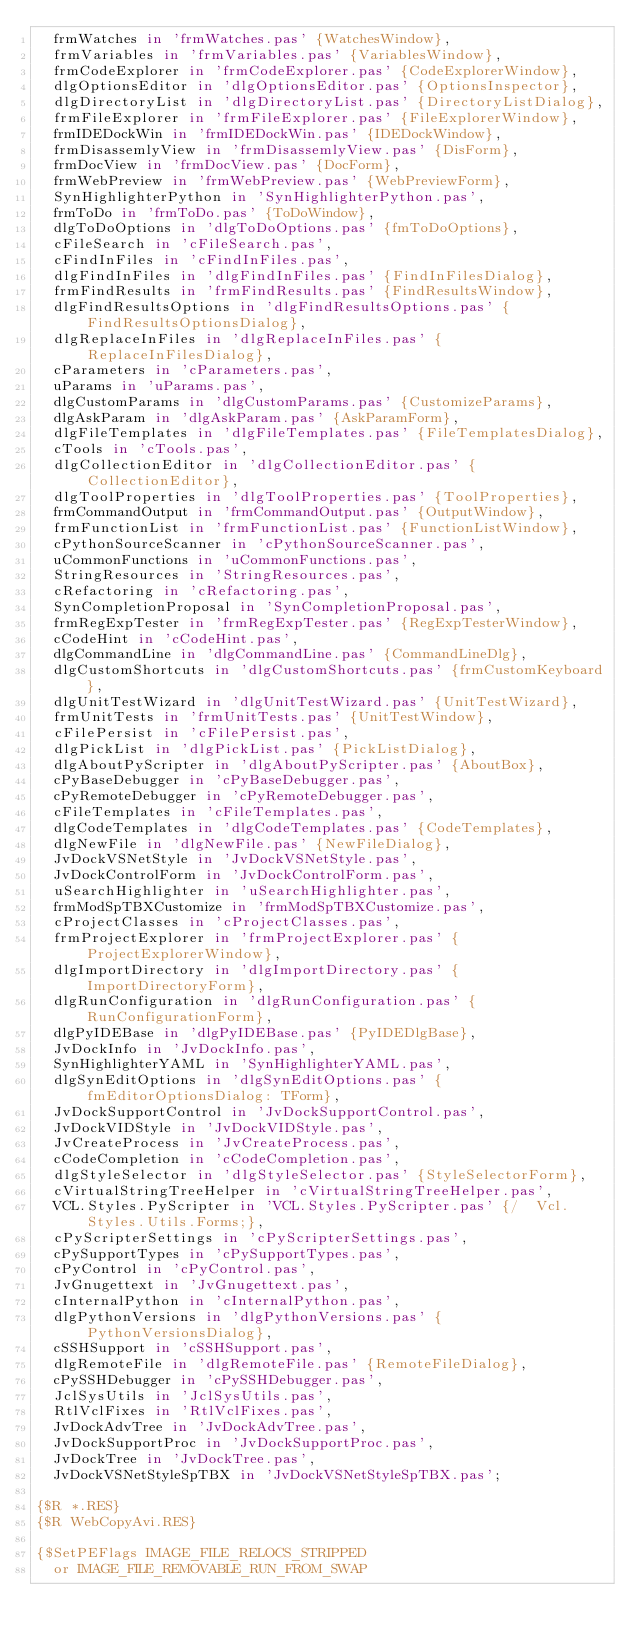<code> <loc_0><loc_0><loc_500><loc_500><_Pascal_>  frmWatches in 'frmWatches.pas' {WatchesWindow},
  frmVariables in 'frmVariables.pas' {VariablesWindow},
  frmCodeExplorer in 'frmCodeExplorer.pas' {CodeExplorerWindow},
  dlgOptionsEditor in 'dlgOptionsEditor.pas' {OptionsInspector},
  dlgDirectoryList in 'dlgDirectoryList.pas' {DirectoryListDialog},
  frmFileExplorer in 'frmFileExplorer.pas' {FileExplorerWindow},
  frmIDEDockWin in 'frmIDEDockWin.pas' {IDEDockWindow},
  frmDisassemlyView in 'frmDisassemlyView.pas' {DisForm},
  frmDocView in 'frmDocView.pas' {DocForm},
  frmWebPreview in 'frmWebPreview.pas' {WebPreviewForm},
  SynHighlighterPython in 'SynHighlighterPython.pas',
  frmToDo in 'frmToDo.pas' {ToDoWindow},
  dlgToDoOptions in 'dlgToDoOptions.pas' {fmToDoOptions},
  cFileSearch in 'cFileSearch.pas',
  cFindInFiles in 'cFindInFiles.pas',
  dlgFindInFiles in 'dlgFindInFiles.pas' {FindInFilesDialog},
  frmFindResults in 'frmFindResults.pas' {FindResultsWindow},
  dlgFindResultsOptions in 'dlgFindResultsOptions.pas' {FindResultsOptionsDialog},
  dlgReplaceInFiles in 'dlgReplaceInFiles.pas' {ReplaceInFilesDialog},
  cParameters in 'cParameters.pas',
  uParams in 'uParams.pas',
  dlgCustomParams in 'dlgCustomParams.pas' {CustomizeParams},
  dlgAskParam in 'dlgAskParam.pas' {AskParamForm},
  dlgFileTemplates in 'dlgFileTemplates.pas' {FileTemplatesDialog},
  cTools in 'cTools.pas',
  dlgCollectionEditor in 'dlgCollectionEditor.pas' {CollectionEditor},
  dlgToolProperties in 'dlgToolProperties.pas' {ToolProperties},
  frmCommandOutput in 'frmCommandOutput.pas' {OutputWindow},
  frmFunctionList in 'frmFunctionList.pas' {FunctionListWindow},
  cPythonSourceScanner in 'cPythonSourceScanner.pas',
  uCommonFunctions in 'uCommonFunctions.pas',
  StringResources in 'StringResources.pas',
  cRefactoring in 'cRefactoring.pas',
  SynCompletionProposal in 'SynCompletionProposal.pas',
  frmRegExpTester in 'frmRegExpTester.pas' {RegExpTesterWindow},
  cCodeHint in 'cCodeHint.pas',
  dlgCommandLine in 'dlgCommandLine.pas' {CommandLineDlg},
  dlgCustomShortcuts in 'dlgCustomShortcuts.pas' {frmCustomKeyboard},
  dlgUnitTestWizard in 'dlgUnitTestWizard.pas' {UnitTestWizard},
  frmUnitTests in 'frmUnitTests.pas' {UnitTestWindow},
  cFilePersist in 'cFilePersist.pas',
  dlgPickList in 'dlgPickList.pas' {PickListDialog},
  dlgAboutPyScripter in 'dlgAboutPyScripter.pas' {AboutBox},
  cPyBaseDebugger in 'cPyBaseDebugger.pas',
  cPyRemoteDebugger in 'cPyRemoteDebugger.pas',
  cFileTemplates in 'cFileTemplates.pas',
  dlgCodeTemplates in 'dlgCodeTemplates.pas' {CodeTemplates},
  dlgNewFile in 'dlgNewFile.pas' {NewFileDialog},
  JvDockVSNetStyle in 'JvDockVSNetStyle.pas',
  JvDockControlForm in 'JvDockControlForm.pas',
  uSearchHighlighter in 'uSearchHighlighter.pas',
  frmModSpTBXCustomize in 'frmModSpTBXCustomize.pas',
  cProjectClasses in 'cProjectClasses.pas',
  frmProjectExplorer in 'frmProjectExplorer.pas' {ProjectExplorerWindow},
  dlgImportDirectory in 'dlgImportDirectory.pas' {ImportDirectoryForm},
  dlgRunConfiguration in 'dlgRunConfiguration.pas' {RunConfigurationForm},
  dlgPyIDEBase in 'dlgPyIDEBase.pas' {PyIDEDlgBase},
  JvDockInfo in 'JvDockInfo.pas',
  SynHighlighterYAML in 'SynHighlighterYAML.pas',
  dlgSynEditOptions in 'dlgSynEditOptions.pas' {fmEditorOptionsDialog: TForm},
  JvDockSupportControl in 'JvDockSupportControl.pas',
  JvDockVIDStyle in 'JvDockVIDStyle.pas',
  JvCreateProcess in 'JvCreateProcess.pas',
  cCodeCompletion in 'cCodeCompletion.pas',
  dlgStyleSelector in 'dlgStyleSelector.pas' {StyleSelectorForm},
  cVirtualStringTreeHelper in 'cVirtualStringTreeHelper.pas',
  VCL.Styles.PyScripter in 'VCL.Styles.PyScripter.pas' {/  Vcl.Styles.Utils.Forms;},
  cPyScripterSettings in 'cPyScripterSettings.pas',
  cPySupportTypes in 'cPySupportTypes.pas',
  cPyControl in 'cPyControl.pas',
  JvGnugettext in 'JvGnugettext.pas',
  cInternalPython in 'cInternalPython.pas',
  dlgPythonVersions in 'dlgPythonVersions.pas' {PythonVersionsDialog},
  cSSHSupport in 'cSSHSupport.pas',
  dlgRemoteFile in 'dlgRemoteFile.pas' {RemoteFileDialog},
  cPySSHDebugger in 'cPySSHDebugger.pas',
  JclSysUtils in 'JclSysUtils.pas',
  RtlVclFixes in 'RtlVclFixes.pas',
  JvDockAdvTree in 'JvDockAdvTree.pas',
  JvDockSupportProc in 'JvDockSupportProc.pas',
  JvDockTree in 'JvDockTree.pas',
  JvDockVSNetStyleSpTBX in 'JvDockVSNetStyleSpTBX.pas';

{$R *.RES}
{$R WebCopyAvi.RES}

{$SetPEFlags IMAGE_FILE_RELOCS_STRIPPED
  or IMAGE_FILE_REMOVABLE_RUN_FROM_SWAP</code> 